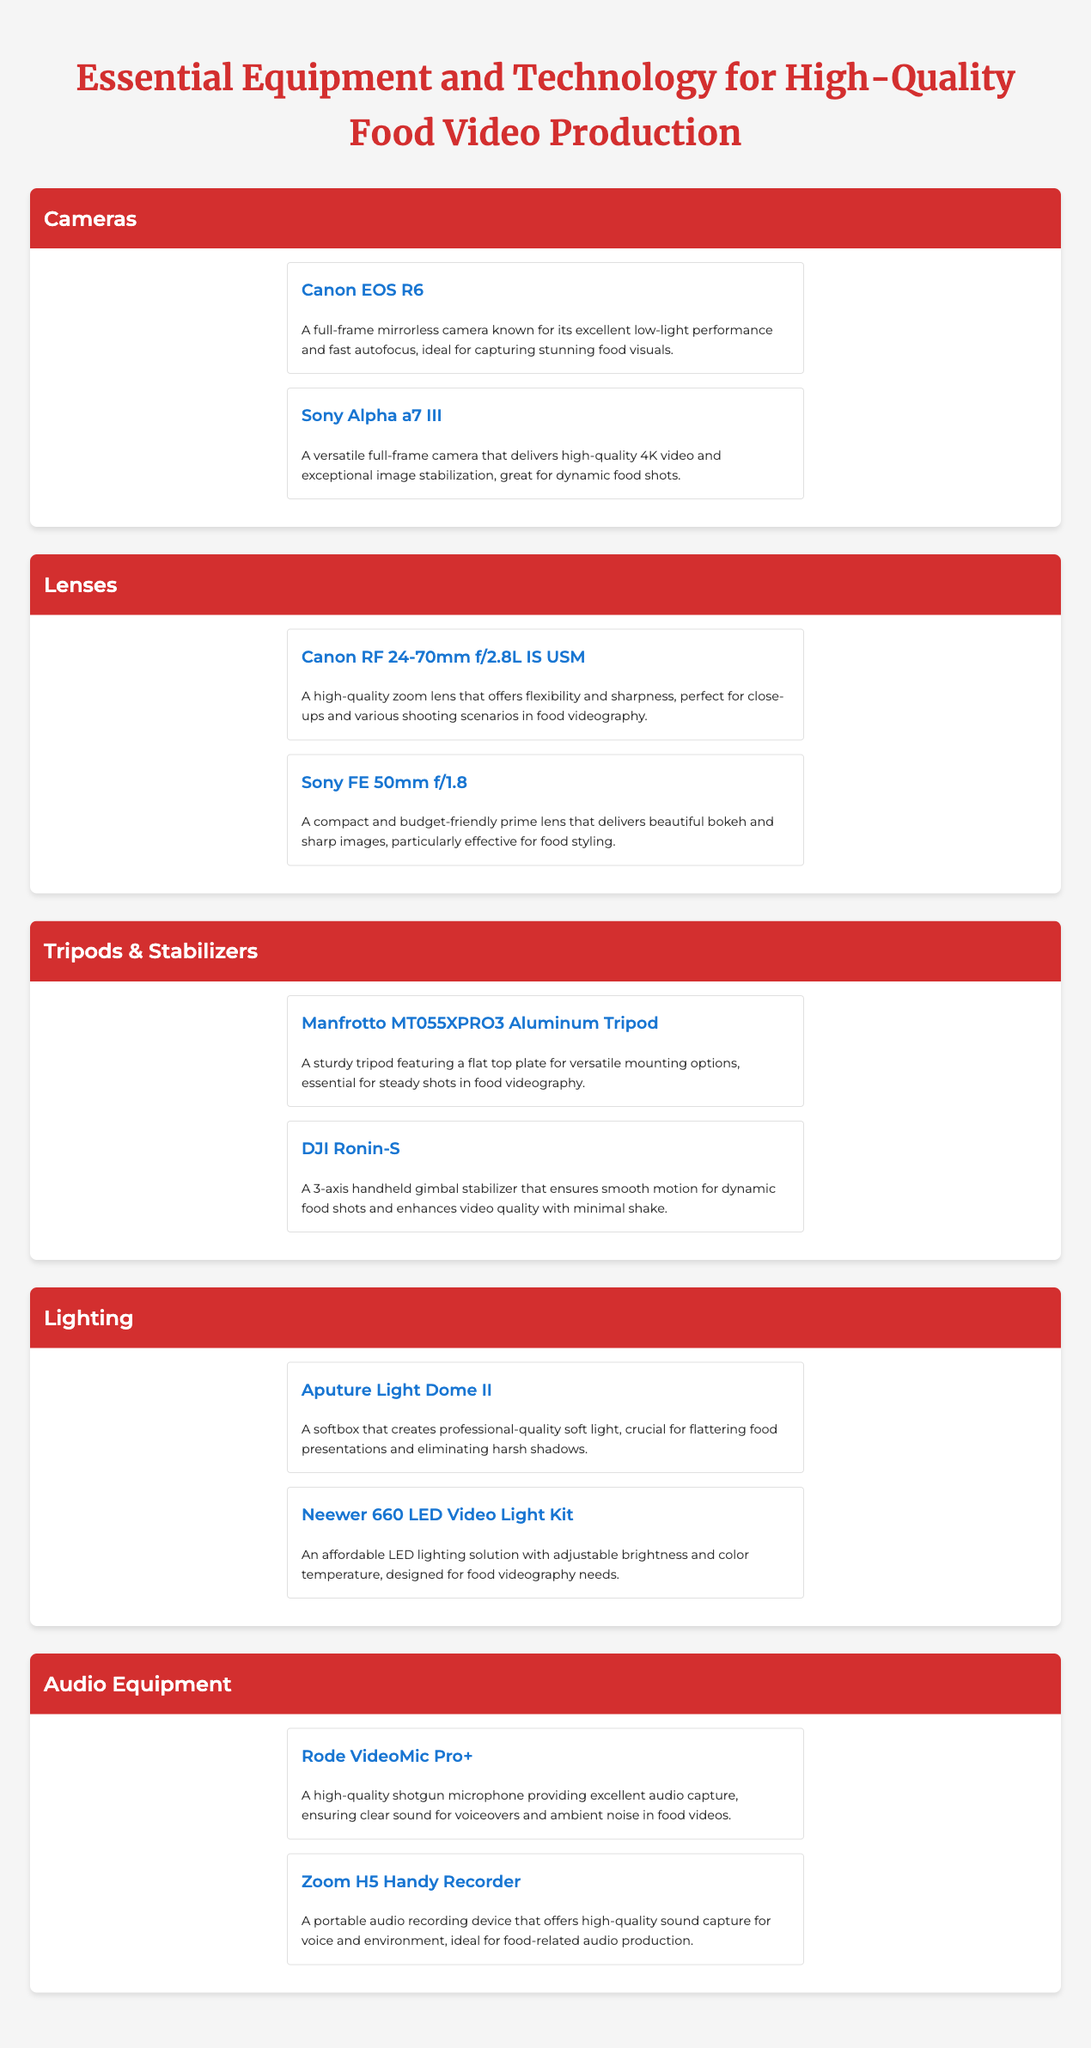what is the title of the document? The title is presented at the top of the document, which encapsulates the main theme.
Answer: Essential Equipment and Technology for High-Quality Food Video Production how many camera models are listed? The document contains a specific category for cameras and lists all models under it.
Answer: 2 which tripod model is mentioned? The tripod section outlines specific products, identifying models available for food video production.
Answer: Manfrotto MT055XPRO3 Aluminum Tripod what type of lighting equipment is included? The lighting category features products that are crucial for food videography.
Answer: Aputure Light Dome II who is the brand of the shotgun microphone? The audio equipment section specifies brands associated with the listed products.
Answer: Rode which lens offers beautiful bokeh? The lens section discusses the effects that different models provide, including aesthetics.
Answer: Sony FE 50mm f/1.8 how many categories of equipment are there? The document is structured into distinct sections, each focusing on a type of equipment, indicating the overall organization.
Answer: 5 what is the purpose of the DJI Ronin-S? The information provides insights on what each stabilizer contributes to video production.
Answer: Smooth motion for dynamic food shots which brand offers an affordable LED lighting solution? The document highlights specific budget-friendly products, helping identify cost-effective options in lighting.
Answer: Neewer 